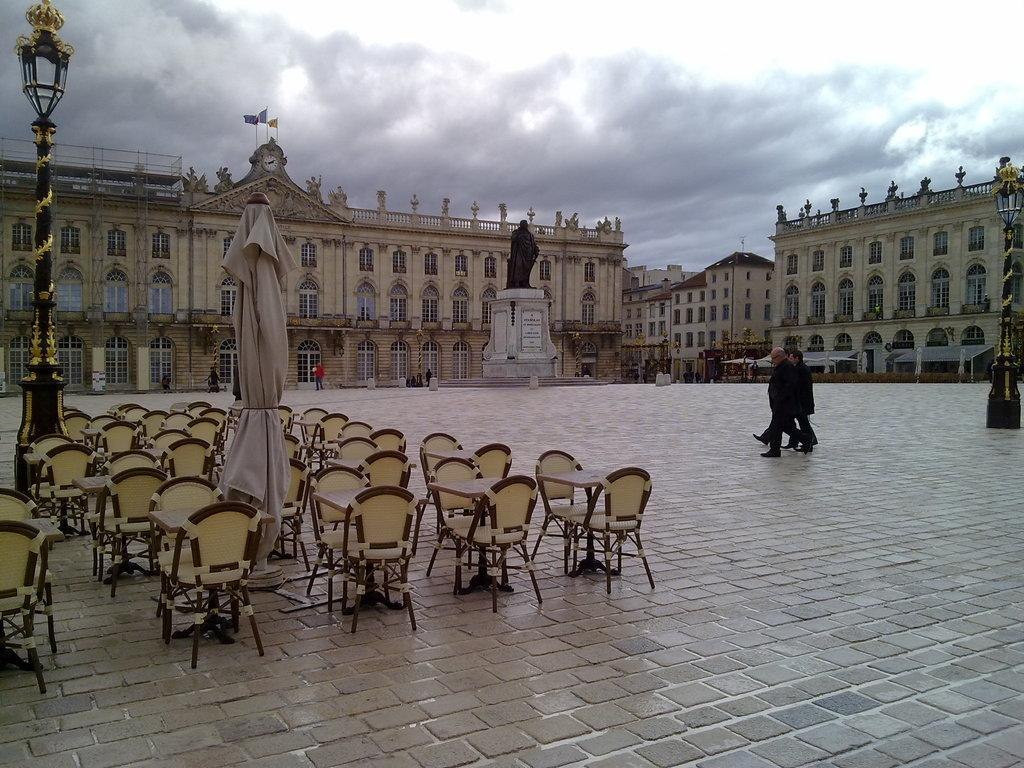What is the main subject on the platform in the image? There is a statue on a platform in the image. What else can be seen in the image besides the statue? There are people, chairs, poles, objects on the ground, buildings, flags, and the sky visible in the image. What might the people in the image be using the chairs for? The chairs might be used for sitting or resting. What can be seen in the background of the image? Buildings, flags, and the sky can be seen in the background of the image. What type of berry is being used as a key in the image? There is no berry or key present in the image. 